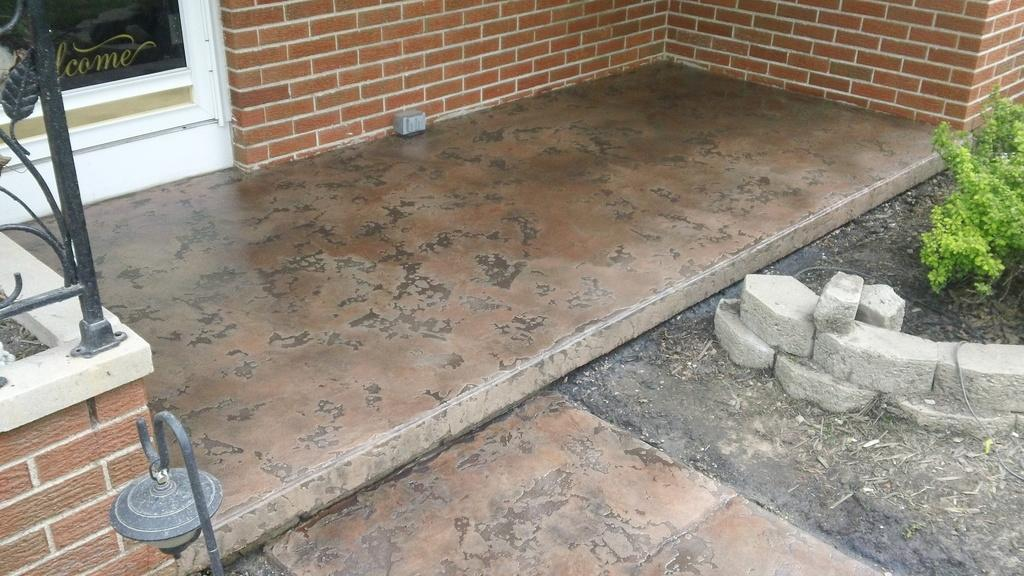What type of material is used for the rods in the image? The rods in the image are made of metal. What is written or displayed on the glass surface in the image? There is text on a glass surface in the image. What can be seen on the right side of the image? There are bricks and a plant on the right side of the image. Who is the owner of the pencil in the image? There is no pencil present in the image. How many sticks are visible in the image? There are no sticks visible in the image. 